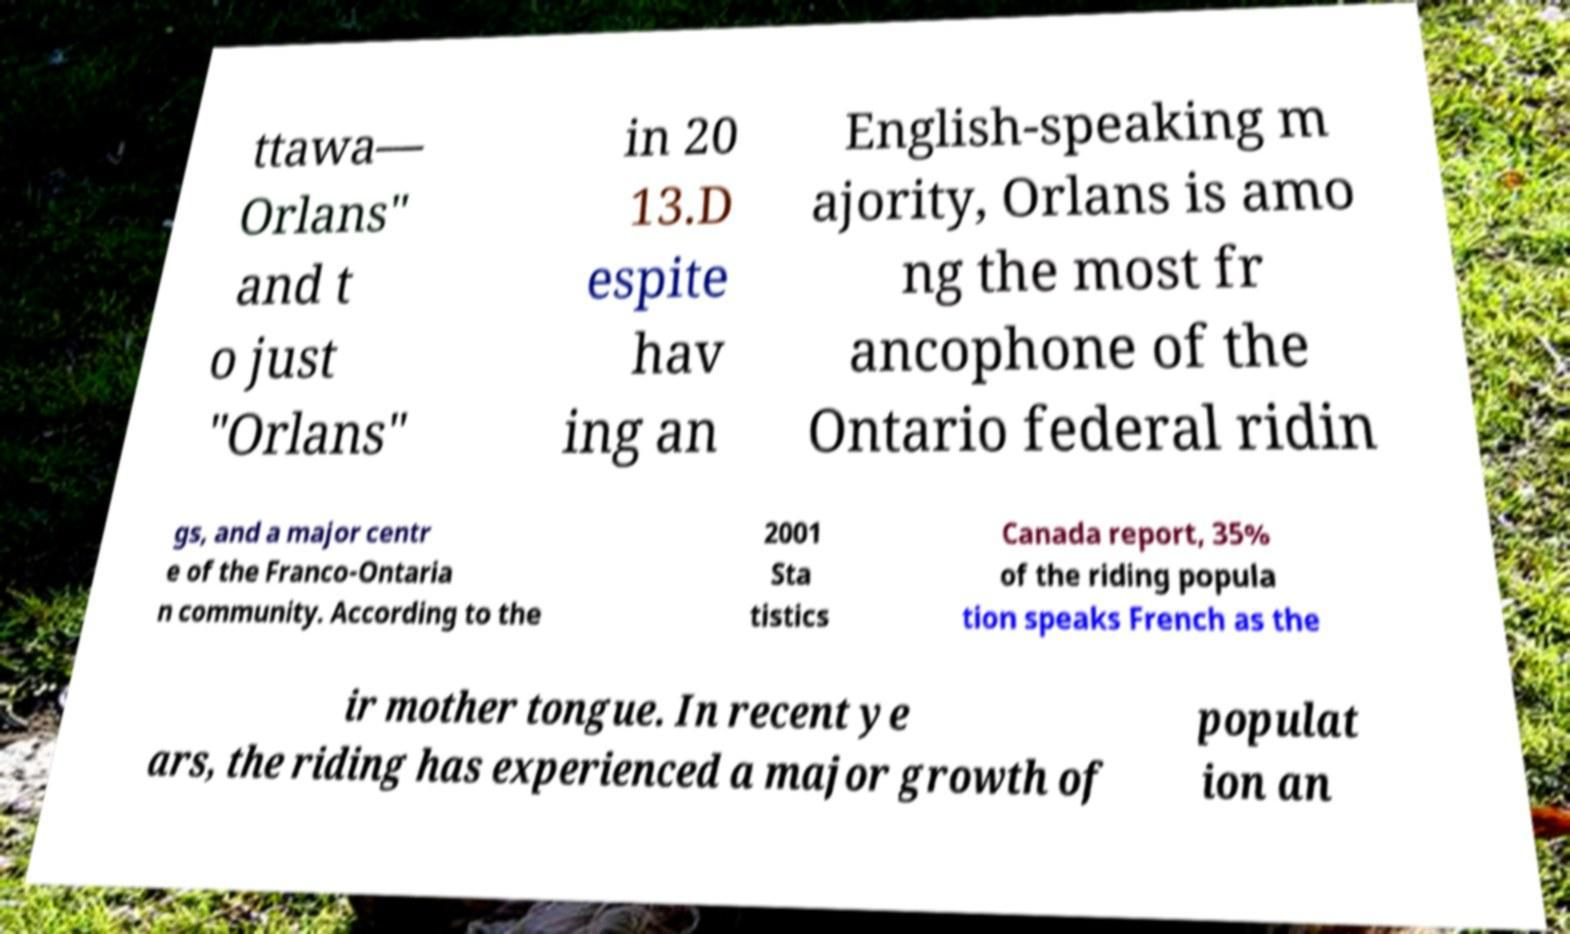For documentation purposes, I need the text within this image transcribed. Could you provide that? ttawa— Orlans" and t o just "Orlans" in 20 13.D espite hav ing an English-speaking m ajority, Orlans is amo ng the most fr ancophone of the Ontario federal ridin gs, and a major centr e of the Franco-Ontaria n community. According to the 2001 Sta tistics Canada report, 35% of the riding popula tion speaks French as the ir mother tongue. In recent ye ars, the riding has experienced a major growth of populat ion an 